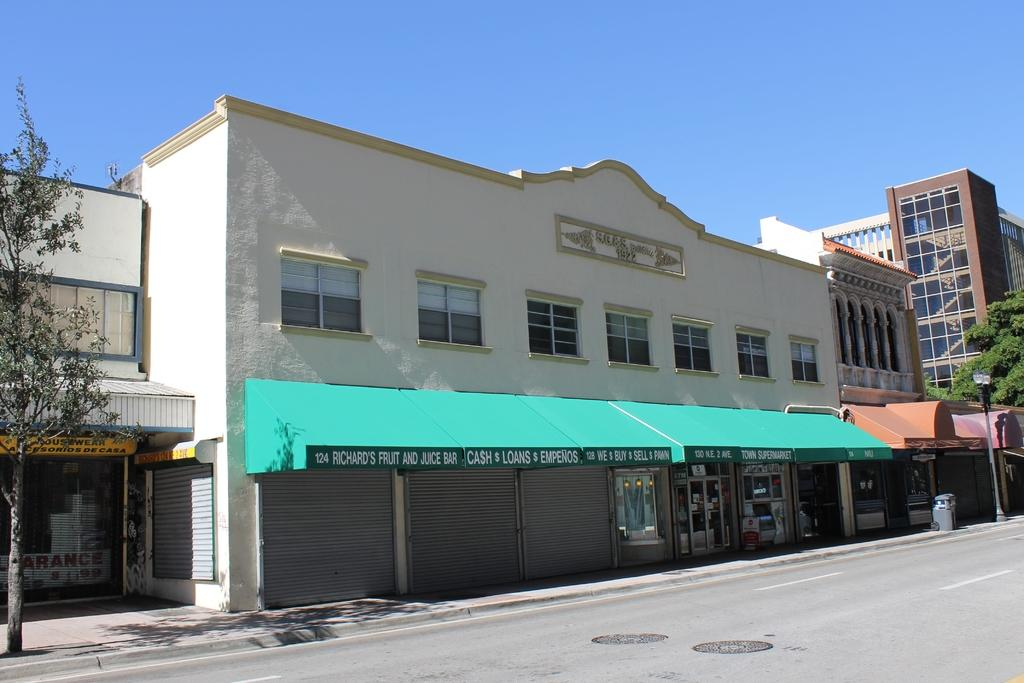What type of structures can be seen in the image? There are buildings in the image. What other natural elements are present in the image? There are trees in the image. What type of lighting is present on the sidewalk? There is a pole light on the sidewalk in the image. What object is present for waste disposal? There is a dustbin in the image. What color is the sky in the image? The sky is blue in the image. Can you see the steam coming out of the buildings in the image? There is no steam visible in the image. How many brothers are standing near the dustbin in the image? There are no people, let alone brothers, present in the image. 